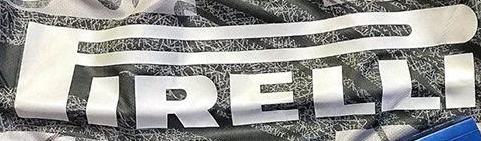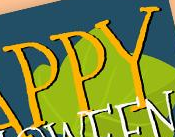Read the text from these images in sequence, separated by a semicolon. PIRELLI; PPY 